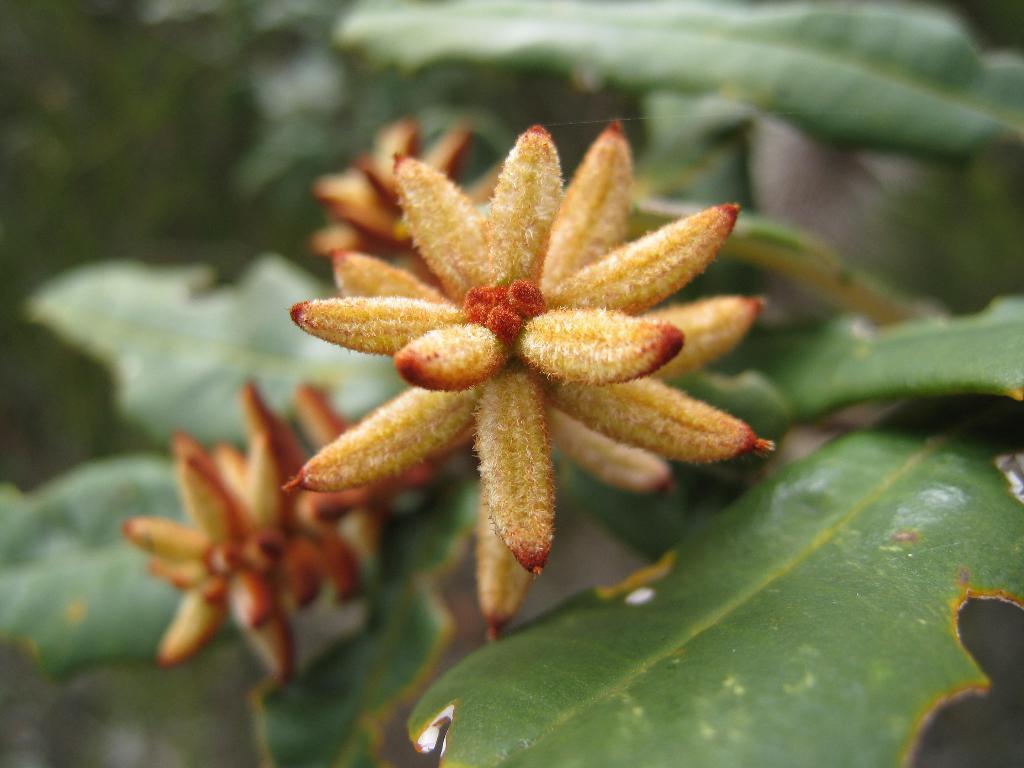Could you give a brief overview of what you see in this image? In this image we can see a flower and leaves of a plant. 